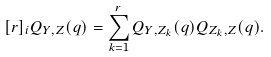Convert formula to latex. <formula><loc_0><loc_0><loc_500><loc_500>[ r ] _ { i } Q _ { Y , Z } ( q ) = \sum _ { k = 1 } ^ { r } Q _ { Y , Z _ { k } } ( q ) Q _ { Z _ { k } , Z } ( q ) .</formula> 